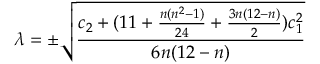<formula> <loc_0><loc_0><loc_500><loc_500>\lambda = \pm \sqrt { \frac { c _ { 2 } + ( 1 1 + \frac { n ( n ^ { 2 } - 1 ) } { 2 4 } + \frac { 3 n ( 1 2 - n ) } { 2 } ) c _ { 1 } ^ { 2 } } { 6 n ( 1 2 - n ) } }</formula> 